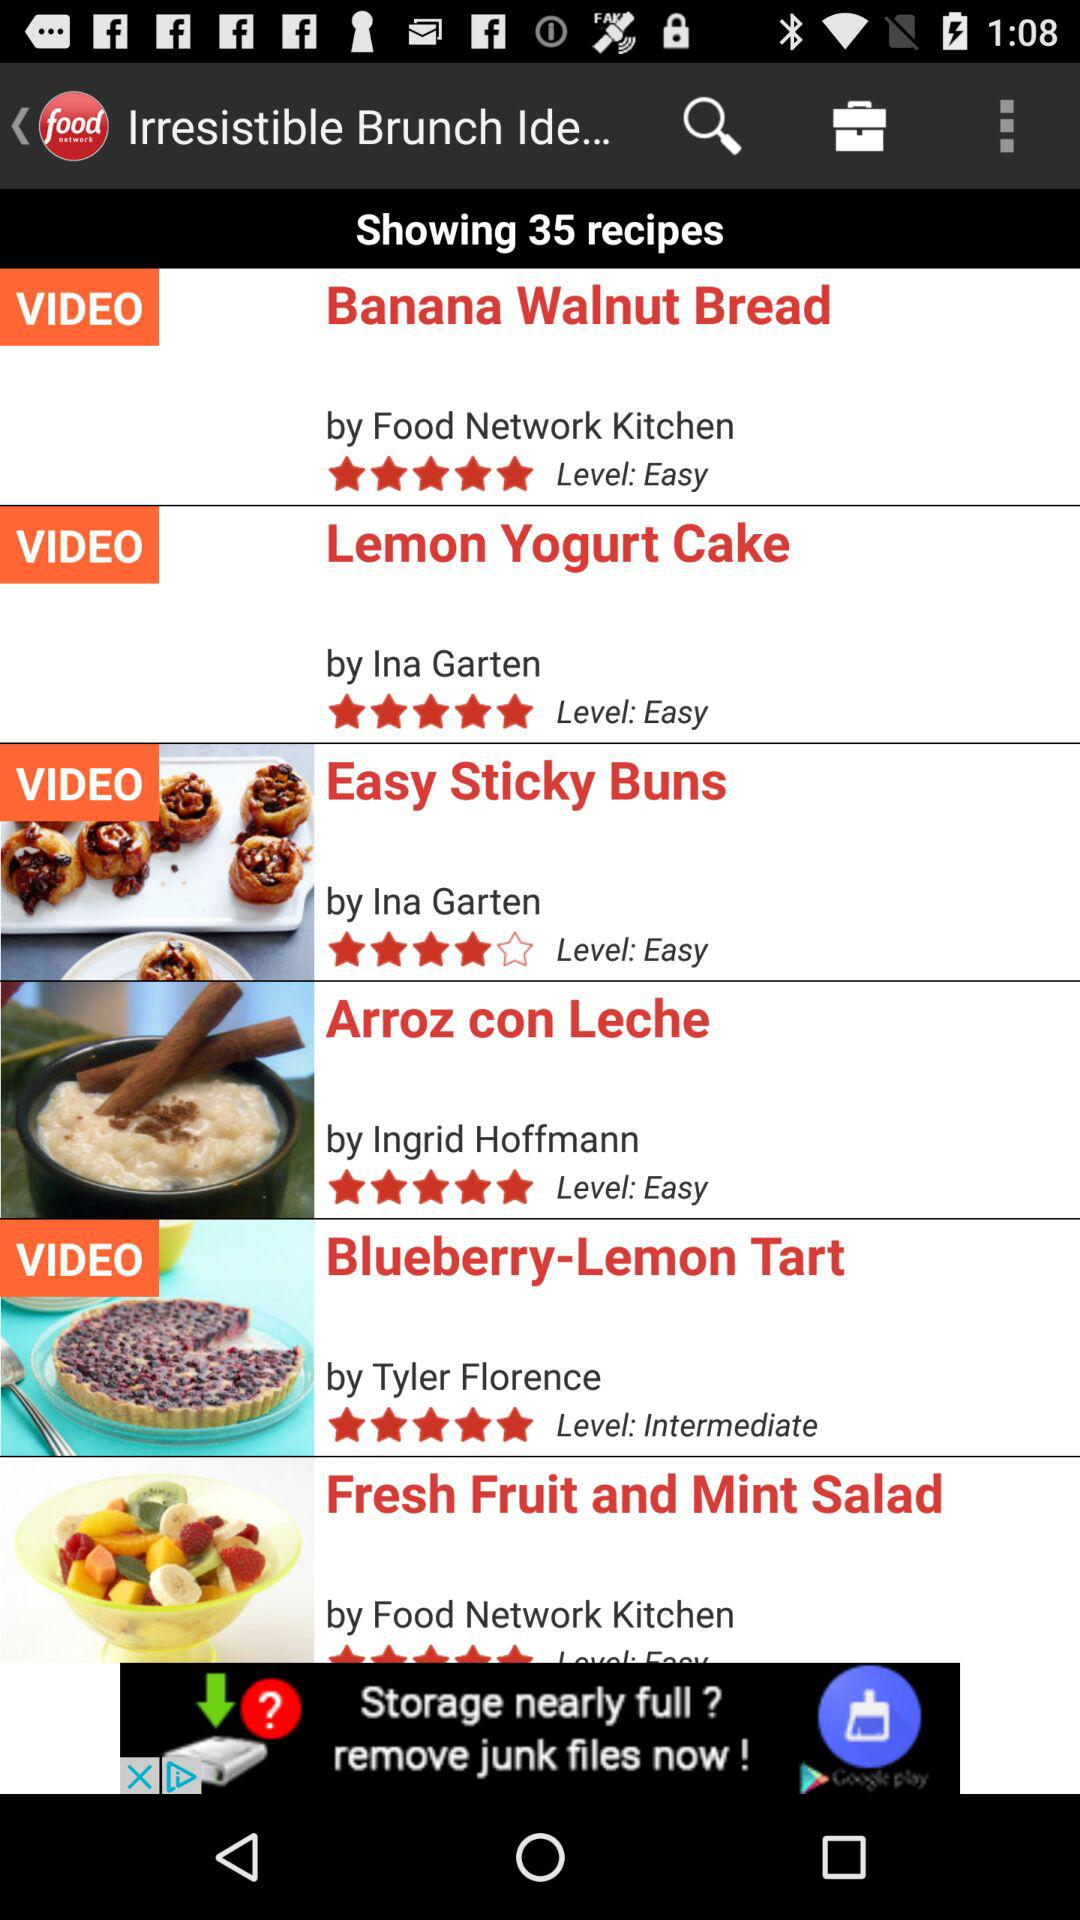What is the rating of Easy Sticky Buns? The rating is 4. 